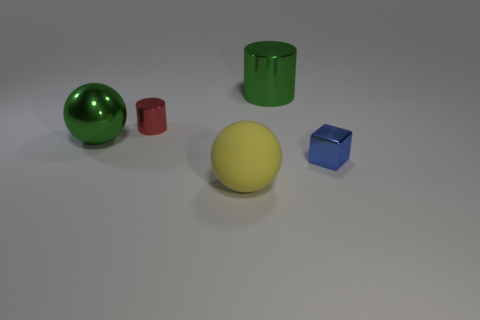Add 1 big metallic spheres. How many objects exist? 6 Subtract all balls. How many objects are left? 3 Subtract 1 balls. How many balls are left? 1 Subtract 1 yellow spheres. How many objects are left? 4 Subtract all yellow cylinders. Subtract all red blocks. How many cylinders are left? 2 Subtract all gray cylinders. How many purple blocks are left? 0 Subtract all large rubber spheres. Subtract all tiny metallic objects. How many objects are left? 2 Add 1 red cylinders. How many red cylinders are left? 2 Add 3 tiny red cylinders. How many tiny red cylinders exist? 4 